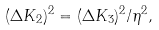<formula> <loc_0><loc_0><loc_500><loc_500>( \Delta K _ { 2 } ) ^ { 2 } = ( \Delta K _ { 3 } ) ^ { 2 } / \eta ^ { 2 } ,</formula> 